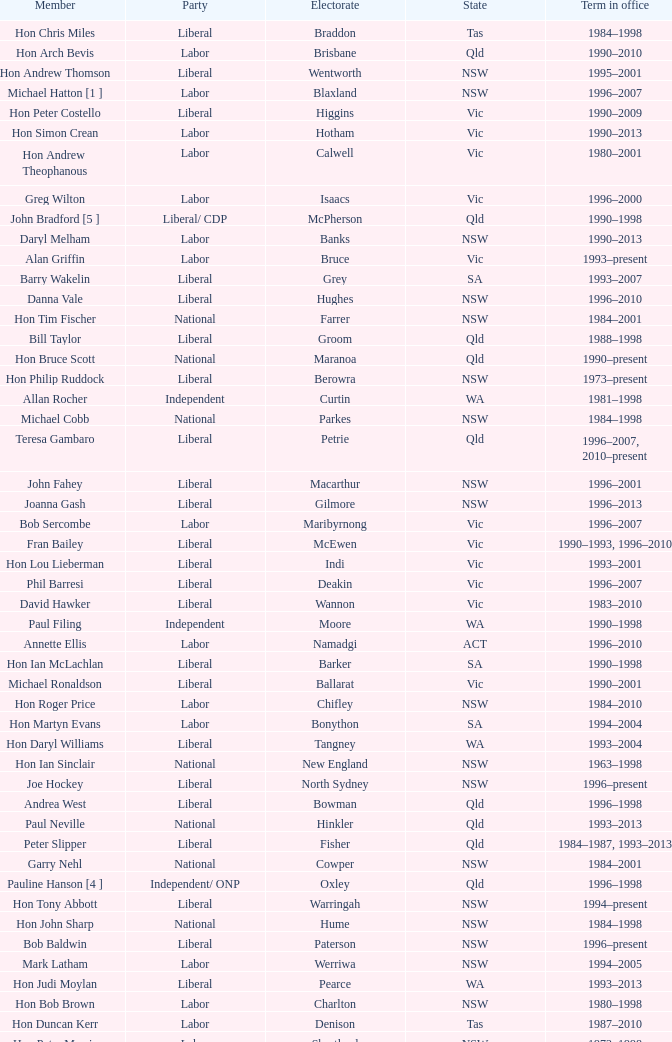In what state was the electorate fowler? NSW. 